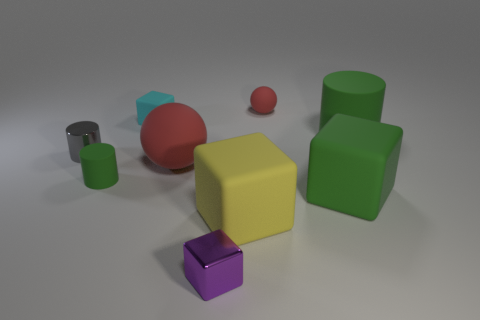Subtract all large rubber cylinders. How many cylinders are left? 2 Add 1 big yellow things. How many objects exist? 10 Subtract all yellow cubes. How many cubes are left? 3 Subtract all blue blocks. How many green cylinders are left? 2 Subtract 1 balls. How many balls are left? 1 Subtract all cyan blocks. Subtract all blue cylinders. How many blocks are left? 3 Subtract all blue rubber balls. Subtract all big green rubber objects. How many objects are left? 7 Add 4 red matte objects. How many red matte objects are left? 6 Add 7 small green cylinders. How many small green cylinders exist? 8 Subtract 0 gray blocks. How many objects are left? 9 